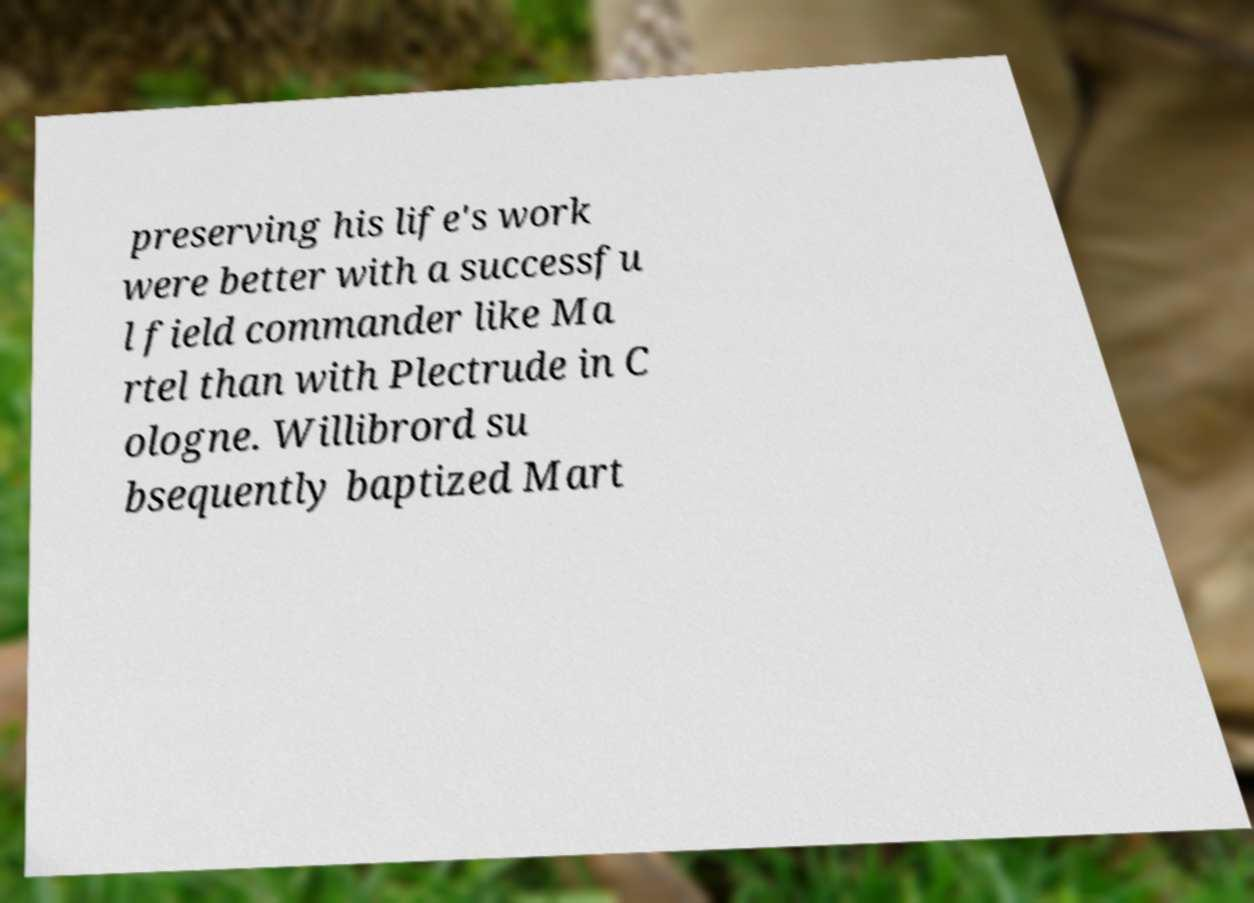Please identify and transcribe the text found in this image. preserving his life's work were better with a successfu l field commander like Ma rtel than with Plectrude in C ologne. Willibrord su bsequently baptized Mart 